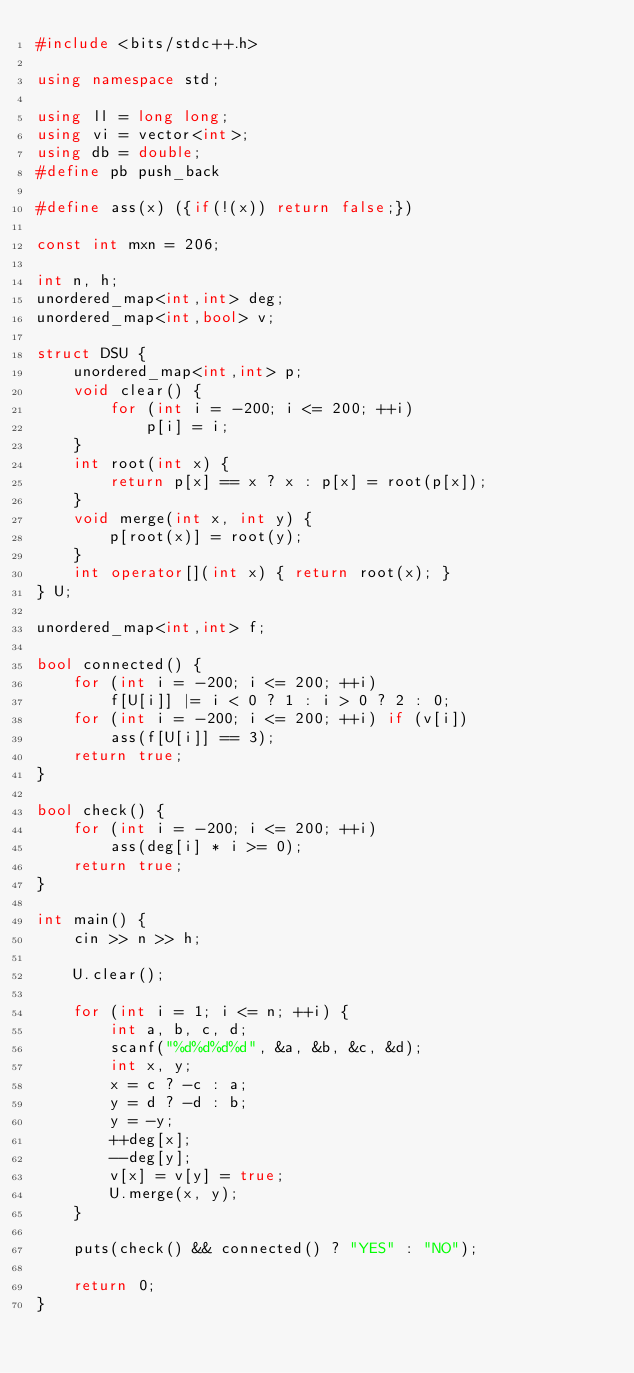<code> <loc_0><loc_0><loc_500><loc_500><_C++_>#include <bits/stdc++.h>

using namespace std;

using ll = long long;
using vi = vector<int>;
using db = double;
#define pb push_back

#define ass(x) ({if(!(x)) return false;})

const int mxn = 206;

int n, h;
unordered_map<int,int> deg;
unordered_map<int,bool> v;

struct DSU {
	unordered_map<int,int> p;
	void clear() {
		for (int i = -200; i <= 200; ++i)
			p[i] = i;
	}
	int root(int x) {
		return p[x] == x ? x : p[x] = root(p[x]);
	}
	void merge(int x, int y) {
		p[root(x)] = root(y);
	}
	int operator[](int x) { return root(x); }
} U;

unordered_map<int,int> f;

bool connected() {
	for (int i = -200; i <= 200; ++i)
		f[U[i]] |= i < 0 ? 1 : i > 0 ? 2 : 0;
	for (int i = -200; i <= 200; ++i) if (v[i])
		ass(f[U[i]] == 3);
	return true;
}

bool check() {
	for (int i = -200; i <= 200; ++i)
		ass(deg[i] * i >= 0);
	return true;
}

int main() {
	cin >> n >> h;
	
	U.clear();
	
	for (int i = 1; i <= n; ++i) {
		int a, b, c, d;
		scanf("%d%d%d%d", &a, &b, &c, &d);
		int x, y;
		x = c ? -c : a;
		y = d ? -d : b;
		y = -y;
		++deg[x];
		--deg[y];
		v[x] = v[y] = true;
		U.merge(x, y);
	}
	
	puts(check() && connected() ? "YES" : "NO");
	
	return 0;
}
</code> 